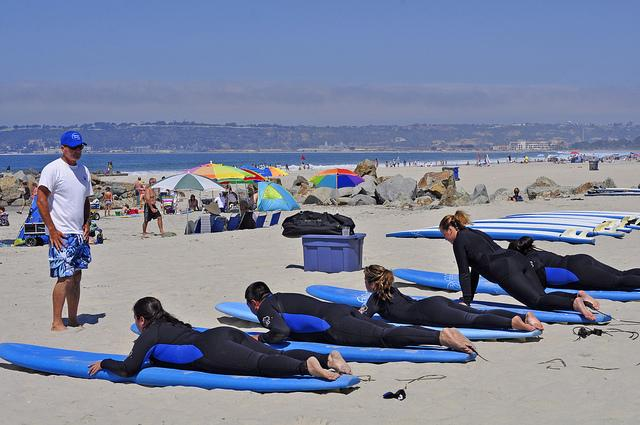What are the people on the blue boards doing? practicing 